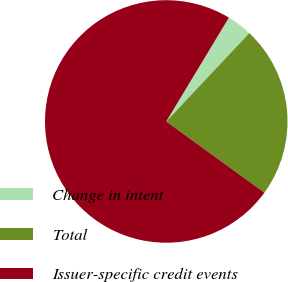Convert chart to OTSL. <chart><loc_0><loc_0><loc_500><loc_500><pie_chart><fcel>Change in intent<fcel>Total<fcel>Issuer-specific credit events<nl><fcel>3.37%<fcel>22.98%<fcel>73.65%<nl></chart> 